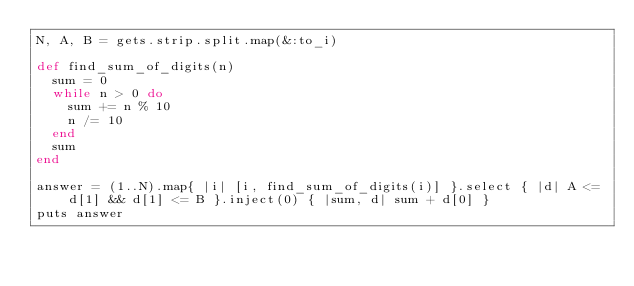<code> <loc_0><loc_0><loc_500><loc_500><_Ruby_>N, A, B = gets.strip.split.map(&:to_i)

def find_sum_of_digits(n)
  sum = 0
  while n > 0 do
    sum += n % 10
    n /= 10
  end
  sum
end

answer = (1..N).map{ |i| [i, find_sum_of_digits(i)] }.select { |d| A <= d[1] && d[1] <= B }.inject(0) { |sum, d| sum + d[0] }
puts answer</code> 